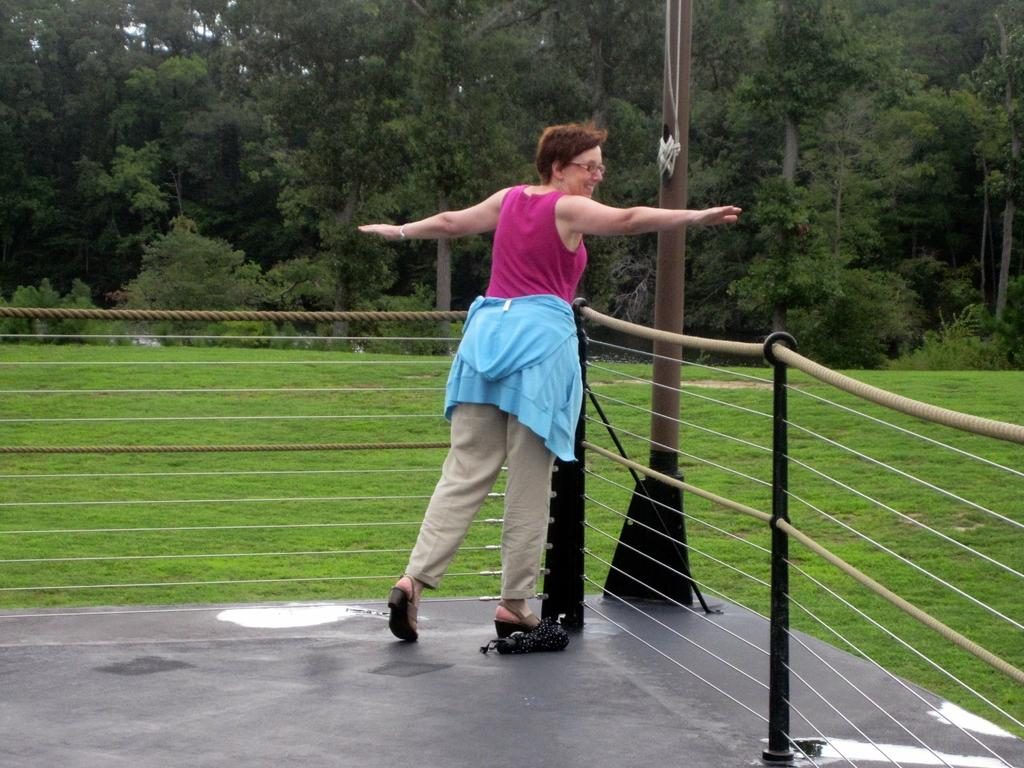What is the main subject of the image? There is a woman standing in the center of the image. What is the woman doing in the image? The woman is smiling. What can be seen in the image besides the woman? There is a fence, a pole, grass on the ground, and trees in the background of the image. What type of pear is the woman holding in the image? There is no pear present in the image; the woman is not holding anything. What type of apparel is the woman wearing in the image? The provided facts do not mention the woman's clothing, so we cannot determine the type of apparel she is wearing. 